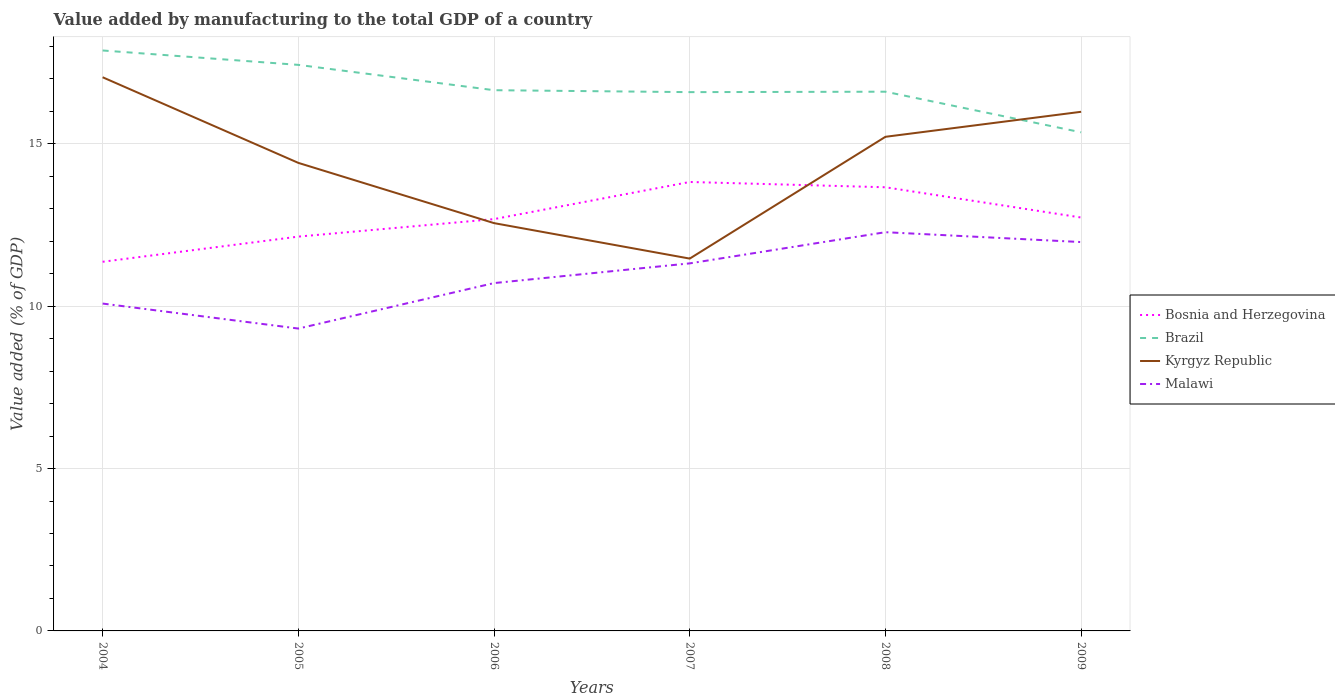How many different coloured lines are there?
Provide a succinct answer. 4. Does the line corresponding to Malawi intersect with the line corresponding to Kyrgyz Republic?
Keep it short and to the point. No. Across all years, what is the maximum value added by manufacturing to the total GDP in Kyrgyz Republic?
Your answer should be compact. 11.47. What is the total value added by manufacturing to the total GDP in Bosnia and Herzegovina in the graph?
Your response must be concise. -2.29. What is the difference between the highest and the second highest value added by manufacturing to the total GDP in Bosnia and Herzegovina?
Provide a short and direct response. 2.46. What is the difference between the highest and the lowest value added by manufacturing to the total GDP in Brazil?
Your response must be concise. 2. How many lines are there?
Your answer should be compact. 4. How many years are there in the graph?
Provide a succinct answer. 6. What is the difference between two consecutive major ticks on the Y-axis?
Give a very brief answer. 5. Does the graph contain any zero values?
Give a very brief answer. No. Where does the legend appear in the graph?
Your answer should be very brief. Center right. What is the title of the graph?
Give a very brief answer. Value added by manufacturing to the total GDP of a country. Does "Equatorial Guinea" appear as one of the legend labels in the graph?
Provide a short and direct response. No. What is the label or title of the X-axis?
Provide a succinct answer. Years. What is the label or title of the Y-axis?
Provide a succinct answer. Value added (% of GDP). What is the Value added (% of GDP) of Bosnia and Herzegovina in 2004?
Keep it short and to the point. 11.37. What is the Value added (% of GDP) of Brazil in 2004?
Your answer should be compact. 17.88. What is the Value added (% of GDP) in Kyrgyz Republic in 2004?
Your answer should be compact. 17.05. What is the Value added (% of GDP) of Malawi in 2004?
Give a very brief answer. 10.08. What is the Value added (% of GDP) in Bosnia and Herzegovina in 2005?
Your answer should be compact. 12.14. What is the Value added (% of GDP) of Brazil in 2005?
Your answer should be very brief. 17.43. What is the Value added (% of GDP) in Kyrgyz Republic in 2005?
Make the answer very short. 14.41. What is the Value added (% of GDP) of Malawi in 2005?
Provide a succinct answer. 9.31. What is the Value added (% of GDP) of Bosnia and Herzegovina in 2006?
Your response must be concise. 12.68. What is the Value added (% of GDP) in Brazil in 2006?
Make the answer very short. 16.65. What is the Value added (% of GDP) in Kyrgyz Republic in 2006?
Make the answer very short. 12.56. What is the Value added (% of GDP) of Malawi in 2006?
Make the answer very short. 10.71. What is the Value added (% of GDP) of Bosnia and Herzegovina in 2007?
Offer a terse response. 13.83. What is the Value added (% of GDP) in Brazil in 2007?
Your response must be concise. 16.59. What is the Value added (% of GDP) of Kyrgyz Republic in 2007?
Your answer should be compact. 11.47. What is the Value added (% of GDP) in Malawi in 2007?
Provide a short and direct response. 11.32. What is the Value added (% of GDP) of Bosnia and Herzegovina in 2008?
Keep it short and to the point. 13.66. What is the Value added (% of GDP) of Brazil in 2008?
Offer a very short reply. 16.61. What is the Value added (% of GDP) in Kyrgyz Republic in 2008?
Provide a succinct answer. 15.22. What is the Value added (% of GDP) in Malawi in 2008?
Offer a terse response. 12.28. What is the Value added (% of GDP) of Bosnia and Herzegovina in 2009?
Your response must be concise. 12.73. What is the Value added (% of GDP) of Brazil in 2009?
Your answer should be very brief. 15.36. What is the Value added (% of GDP) of Kyrgyz Republic in 2009?
Your response must be concise. 15.99. What is the Value added (% of GDP) of Malawi in 2009?
Provide a succinct answer. 11.98. Across all years, what is the maximum Value added (% of GDP) in Bosnia and Herzegovina?
Make the answer very short. 13.83. Across all years, what is the maximum Value added (% of GDP) of Brazil?
Make the answer very short. 17.88. Across all years, what is the maximum Value added (% of GDP) in Kyrgyz Republic?
Your response must be concise. 17.05. Across all years, what is the maximum Value added (% of GDP) in Malawi?
Provide a short and direct response. 12.28. Across all years, what is the minimum Value added (% of GDP) in Bosnia and Herzegovina?
Offer a terse response. 11.37. Across all years, what is the minimum Value added (% of GDP) of Brazil?
Keep it short and to the point. 15.36. Across all years, what is the minimum Value added (% of GDP) in Kyrgyz Republic?
Your answer should be compact. 11.47. Across all years, what is the minimum Value added (% of GDP) in Malawi?
Keep it short and to the point. 9.31. What is the total Value added (% of GDP) in Bosnia and Herzegovina in the graph?
Your answer should be very brief. 76.42. What is the total Value added (% of GDP) of Brazil in the graph?
Offer a very short reply. 100.52. What is the total Value added (% of GDP) of Kyrgyz Republic in the graph?
Offer a very short reply. 86.7. What is the total Value added (% of GDP) of Malawi in the graph?
Keep it short and to the point. 65.68. What is the difference between the Value added (% of GDP) of Bosnia and Herzegovina in 2004 and that in 2005?
Keep it short and to the point. -0.78. What is the difference between the Value added (% of GDP) of Brazil in 2004 and that in 2005?
Your answer should be compact. 0.44. What is the difference between the Value added (% of GDP) of Kyrgyz Republic in 2004 and that in 2005?
Your response must be concise. 2.64. What is the difference between the Value added (% of GDP) of Malawi in 2004 and that in 2005?
Your answer should be very brief. 0.77. What is the difference between the Value added (% of GDP) in Bosnia and Herzegovina in 2004 and that in 2006?
Keep it short and to the point. -1.31. What is the difference between the Value added (% of GDP) of Brazil in 2004 and that in 2006?
Keep it short and to the point. 1.22. What is the difference between the Value added (% of GDP) of Kyrgyz Republic in 2004 and that in 2006?
Your answer should be compact. 4.49. What is the difference between the Value added (% of GDP) in Malawi in 2004 and that in 2006?
Your answer should be compact. -0.63. What is the difference between the Value added (% of GDP) of Bosnia and Herzegovina in 2004 and that in 2007?
Your answer should be very brief. -2.46. What is the difference between the Value added (% of GDP) of Brazil in 2004 and that in 2007?
Provide a succinct answer. 1.28. What is the difference between the Value added (% of GDP) in Kyrgyz Republic in 2004 and that in 2007?
Your response must be concise. 5.58. What is the difference between the Value added (% of GDP) of Malawi in 2004 and that in 2007?
Provide a short and direct response. -1.24. What is the difference between the Value added (% of GDP) of Bosnia and Herzegovina in 2004 and that in 2008?
Provide a short and direct response. -2.29. What is the difference between the Value added (% of GDP) of Brazil in 2004 and that in 2008?
Keep it short and to the point. 1.27. What is the difference between the Value added (% of GDP) of Kyrgyz Republic in 2004 and that in 2008?
Your answer should be very brief. 1.83. What is the difference between the Value added (% of GDP) of Malawi in 2004 and that in 2008?
Ensure brevity in your answer.  -2.2. What is the difference between the Value added (% of GDP) of Bosnia and Herzegovina in 2004 and that in 2009?
Make the answer very short. -1.36. What is the difference between the Value added (% of GDP) in Brazil in 2004 and that in 2009?
Ensure brevity in your answer.  2.52. What is the difference between the Value added (% of GDP) of Kyrgyz Republic in 2004 and that in 2009?
Your answer should be very brief. 1.06. What is the difference between the Value added (% of GDP) in Malawi in 2004 and that in 2009?
Your answer should be compact. -1.89. What is the difference between the Value added (% of GDP) of Bosnia and Herzegovina in 2005 and that in 2006?
Your answer should be very brief. -0.54. What is the difference between the Value added (% of GDP) of Brazil in 2005 and that in 2006?
Provide a succinct answer. 0.78. What is the difference between the Value added (% of GDP) in Kyrgyz Republic in 2005 and that in 2006?
Your answer should be very brief. 1.86. What is the difference between the Value added (% of GDP) of Malawi in 2005 and that in 2006?
Your answer should be compact. -1.4. What is the difference between the Value added (% of GDP) of Bosnia and Herzegovina in 2005 and that in 2007?
Provide a short and direct response. -1.68. What is the difference between the Value added (% of GDP) in Brazil in 2005 and that in 2007?
Offer a very short reply. 0.84. What is the difference between the Value added (% of GDP) in Kyrgyz Republic in 2005 and that in 2007?
Your answer should be very brief. 2.95. What is the difference between the Value added (% of GDP) of Malawi in 2005 and that in 2007?
Your answer should be compact. -2.01. What is the difference between the Value added (% of GDP) of Bosnia and Herzegovina in 2005 and that in 2008?
Your answer should be very brief. -1.52. What is the difference between the Value added (% of GDP) of Brazil in 2005 and that in 2008?
Give a very brief answer. 0.83. What is the difference between the Value added (% of GDP) in Kyrgyz Republic in 2005 and that in 2008?
Ensure brevity in your answer.  -0.8. What is the difference between the Value added (% of GDP) in Malawi in 2005 and that in 2008?
Your answer should be very brief. -2.97. What is the difference between the Value added (% of GDP) in Bosnia and Herzegovina in 2005 and that in 2009?
Your answer should be very brief. -0.59. What is the difference between the Value added (% of GDP) of Brazil in 2005 and that in 2009?
Offer a very short reply. 2.08. What is the difference between the Value added (% of GDP) in Kyrgyz Republic in 2005 and that in 2009?
Keep it short and to the point. -1.57. What is the difference between the Value added (% of GDP) of Malawi in 2005 and that in 2009?
Provide a short and direct response. -2.66. What is the difference between the Value added (% of GDP) in Bosnia and Herzegovina in 2006 and that in 2007?
Your answer should be very brief. -1.14. What is the difference between the Value added (% of GDP) of Brazil in 2006 and that in 2007?
Make the answer very short. 0.06. What is the difference between the Value added (% of GDP) in Kyrgyz Republic in 2006 and that in 2007?
Your response must be concise. 1.09. What is the difference between the Value added (% of GDP) of Malawi in 2006 and that in 2007?
Offer a terse response. -0.61. What is the difference between the Value added (% of GDP) in Bosnia and Herzegovina in 2006 and that in 2008?
Ensure brevity in your answer.  -0.98. What is the difference between the Value added (% of GDP) in Brazil in 2006 and that in 2008?
Give a very brief answer. 0.05. What is the difference between the Value added (% of GDP) in Kyrgyz Republic in 2006 and that in 2008?
Your response must be concise. -2.66. What is the difference between the Value added (% of GDP) of Malawi in 2006 and that in 2008?
Keep it short and to the point. -1.57. What is the difference between the Value added (% of GDP) in Bosnia and Herzegovina in 2006 and that in 2009?
Your response must be concise. -0.05. What is the difference between the Value added (% of GDP) in Brazil in 2006 and that in 2009?
Keep it short and to the point. 1.3. What is the difference between the Value added (% of GDP) in Kyrgyz Republic in 2006 and that in 2009?
Offer a terse response. -3.43. What is the difference between the Value added (% of GDP) of Malawi in 2006 and that in 2009?
Ensure brevity in your answer.  -1.26. What is the difference between the Value added (% of GDP) in Bosnia and Herzegovina in 2007 and that in 2008?
Your answer should be very brief. 0.16. What is the difference between the Value added (% of GDP) in Brazil in 2007 and that in 2008?
Give a very brief answer. -0.01. What is the difference between the Value added (% of GDP) of Kyrgyz Republic in 2007 and that in 2008?
Provide a succinct answer. -3.75. What is the difference between the Value added (% of GDP) of Malawi in 2007 and that in 2008?
Make the answer very short. -0.96. What is the difference between the Value added (% of GDP) of Bosnia and Herzegovina in 2007 and that in 2009?
Offer a very short reply. 1.09. What is the difference between the Value added (% of GDP) of Brazil in 2007 and that in 2009?
Your answer should be very brief. 1.24. What is the difference between the Value added (% of GDP) of Kyrgyz Republic in 2007 and that in 2009?
Keep it short and to the point. -4.52. What is the difference between the Value added (% of GDP) in Malawi in 2007 and that in 2009?
Your answer should be very brief. -0.66. What is the difference between the Value added (% of GDP) of Bosnia and Herzegovina in 2008 and that in 2009?
Keep it short and to the point. 0.93. What is the difference between the Value added (% of GDP) in Brazil in 2008 and that in 2009?
Provide a succinct answer. 1.25. What is the difference between the Value added (% of GDP) in Kyrgyz Republic in 2008 and that in 2009?
Your answer should be very brief. -0.77. What is the difference between the Value added (% of GDP) in Malawi in 2008 and that in 2009?
Offer a very short reply. 0.3. What is the difference between the Value added (% of GDP) of Bosnia and Herzegovina in 2004 and the Value added (% of GDP) of Brazil in 2005?
Keep it short and to the point. -6.06. What is the difference between the Value added (% of GDP) of Bosnia and Herzegovina in 2004 and the Value added (% of GDP) of Kyrgyz Republic in 2005?
Your answer should be very brief. -3.05. What is the difference between the Value added (% of GDP) in Bosnia and Herzegovina in 2004 and the Value added (% of GDP) in Malawi in 2005?
Your response must be concise. 2.06. What is the difference between the Value added (% of GDP) of Brazil in 2004 and the Value added (% of GDP) of Kyrgyz Republic in 2005?
Your answer should be very brief. 3.46. What is the difference between the Value added (% of GDP) of Brazil in 2004 and the Value added (% of GDP) of Malawi in 2005?
Offer a terse response. 8.56. What is the difference between the Value added (% of GDP) of Kyrgyz Republic in 2004 and the Value added (% of GDP) of Malawi in 2005?
Give a very brief answer. 7.74. What is the difference between the Value added (% of GDP) in Bosnia and Herzegovina in 2004 and the Value added (% of GDP) in Brazil in 2006?
Give a very brief answer. -5.28. What is the difference between the Value added (% of GDP) of Bosnia and Herzegovina in 2004 and the Value added (% of GDP) of Kyrgyz Republic in 2006?
Your response must be concise. -1.19. What is the difference between the Value added (% of GDP) of Bosnia and Herzegovina in 2004 and the Value added (% of GDP) of Malawi in 2006?
Provide a succinct answer. 0.66. What is the difference between the Value added (% of GDP) of Brazil in 2004 and the Value added (% of GDP) of Kyrgyz Republic in 2006?
Give a very brief answer. 5.32. What is the difference between the Value added (% of GDP) of Brazil in 2004 and the Value added (% of GDP) of Malawi in 2006?
Your answer should be very brief. 7.16. What is the difference between the Value added (% of GDP) of Kyrgyz Republic in 2004 and the Value added (% of GDP) of Malawi in 2006?
Keep it short and to the point. 6.34. What is the difference between the Value added (% of GDP) of Bosnia and Herzegovina in 2004 and the Value added (% of GDP) of Brazil in 2007?
Give a very brief answer. -5.22. What is the difference between the Value added (% of GDP) in Bosnia and Herzegovina in 2004 and the Value added (% of GDP) in Kyrgyz Republic in 2007?
Give a very brief answer. -0.1. What is the difference between the Value added (% of GDP) in Bosnia and Herzegovina in 2004 and the Value added (% of GDP) in Malawi in 2007?
Provide a succinct answer. 0.05. What is the difference between the Value added (% of GDP) in Brazil in 2004 and the Value added (% of GDP) in Kyrgyz Republic in 2007?
Give a very brief answer. 6.41. What is the difference between the Value added (% of GDP) of Brazil in 2004 and the Value added (% of GDP) of Malawi in 2007?
Make the answer very short. 6.56. What is the difference between the Value added (% of GDP) in Kyrgyz Republic in 2004 and the Value added (% of GDP) in Malawi in 2007?
Offer a very short reply. 5.73. What is the difference between the Value added (% of GDP) in Bosnia and Herzegovina in 2004 and the Value added (% of GDP) in Brazil in 2008?
Your answer should be compact. -5.24. What is the difference between the Value added (% of GDP) in Bosnia and Herzegovina in 2004 and the Value added (% of GDP) in Kyrgyz Republic in 2008?
Your answer should be very brief. -3.85. What is the difference between the Value added (% of GDP) in Bosnia and Herzegovina in 2004 and the Value added (% of GDP) in Malawi in 2008?
Your answer should be very brief. -0.91. What is the difference between the Value added (% of GDP) in Brazil in 2004 and the Value added (% of GDP) in Kyrgyz Republic in 2008?
Provide a succinct answer. 2.66. What is the difference between the Value added (% of GDP) in Brazil in 2004 and the Value added (% of GDP) in Malawi in 2008?
Give a very brief answer. 5.6. What is the difference between the Value added (% of GDP) of Kyrgyz Republic in 2004 and the Value added (% of GDP) of Malawi in 2008?
Keep it short and to the point. 4.77. What is the difference between the Value added (% of GDP) in Bosnia and Herzegovina in 2004 and the Value added (% of GDP) in Brazil in 2009?
Offer a very short reply. -3.99. What is the difference between the Value added (% of GDP) in Bosnia and Herzegovina in 2004 and the Value added (% of GDP) in Kyrgyz Republic in 2009?
Provide a succinct answer. -4.62. What is the difference between the Value added (% of GDP) in Bosnia and Herzegovina in 2004 and the Value added (% of GDP) in Malawi in 2009?
Provide a short and direct response. -0.61. What is the difference between the Value added (% of GDP) of Brazil in 2004 and the Value added (% of GDP) of Kyrgyz Republic in 2009?
Your answer should be very brief. 1.89. What is the difference between the Value added (% of GDP) of Brazil in 2004 and the Value added (% of GDP) of Malawi in 2009?
Offer a very short reply. 5.9. What is the difference between the Value added (% of GDP) of Kyrgyz Republic in 2004 and the Value added (% of GDP) of Malawi in 2009?
Ensure brevity in your answer.  5.08. What is the difference between the Value added (% of GDP) in Bosnia and Herzegovina in 2005 and the Value added (% of GDP) in Brazil in 2006?
Give a very brief answer. -4.51. What is the difference between the Value added (% of GDP) of Bosnia and Herzegovina in 2005 and the Value added (% of GDP) of Kyrgyz Republic in 2006?
Offer a terse response. -0.42. What is the difference between the Value added (% of GDP) of Bosnia and Herzegovina in 2005 and the Value added (% of GDP) of Malawi in 2006?
Your answer should be compact. 1.43. What is the difference between the Value added (% of GDP) in Brazil in 2005 and the Value added (% of GDP) in Kyrgyz Republic in 2006?
Your answer should be compact. 4.87. What is the difference between the Value added (% of GDP) of Brazil in 2005 and the Value added (% of GDP) of Malawi in 2006?
Provide a short and direct response. 6.72. What is the difference between the Value added (% of GDP) in Kyrgyz Republic in 2005 and the Value added (% of GDP) in Malawi in 2006?
Your answer should be very brief. 3.7. What is the difference between the Value added (% of GDP) in Bosnia and Herzegovina in 2005 and the Value added (% of GDP) in Brazil in 2007?
Provide a short and direct response. -4.45. What is the difference between the Value added (% of GDP) in Bosnia and Herzegovina in 2005 and the Value added (% of GDP) in Kyrgyz Republic in 2007?
Provide a short and direct response. 0.68. What is the difference between the Value added (% of GDP) of Bosnia and Herzegovina in 2005 and the Value added (% of GDP) of Malawi in 2007?
Offer a terse response. 0.82. What is the difference between the Value added (% of GDP) in Brazil in 2005 and the Value added (% of GDP) in Kyrgyz Republic in 2007?
Give a very brief answer. 5.97. What is the difference between the Value added (% of GDP) of Brazil in 2005 and the Value added (% of GDP) of Malawi in 2007?
Provide a succinct answer. 6.11. What is the difference between the Value added (% of GDP) in Kyrgyz Republic in 2005 and the Value added (% of GDP) in Malawi in 2007?
Offer a terse response. 3.09. What is the difference between the Value added (% of GDP) of Bosnia and Herzegovina in 2005 and the Value added (% of GDP) of Brazil in 2008?
Your response must be concise. -4.46. What is the difference between the Value added (% of GDP) in Bosnia and Herzegovina in 2005 and the Value added (% of GDP) in Kyrgyz Republic in 2008?
Keep it short and to the point. -3.07. What is the difference between the Value added (% of GDP) of Bosnia and Herzegovina in 2005 and the Value added (% of GDP) of Malawi in 2008?
Provide a succinct answer. -0.14. What is the difference between the Value added (% of GDP) of Brazil in 2005 and the Value added (% of GDP) of Kyrgyz Republic in 2008?
Offer a very short reply. 2.22. What is the difference between the Value added (% of GDP) of Brazil in 2005 and the Value added (% of GDP) of Malawi in 2008?
Your response must be concise. 5.15. What is the difference between the Value added (% of GDP) of Kyrgyz Republic in 2005 and the Value added (% of GDP) of Malawi in 2008?
Keep it short and to the point. 2.13. What is the difference between the Value added (% of GDP) in Bosnia and Herzegovina in 2005 and the Value added (% of GDP) in Brazil in 2009?
Your answer should be compact. -3.21. What is the difference between the Value added (% of GDP) in Bosnia and Herzegovina in 2005 and the Value added (% of GDP) in Kyrgyz Republic in 2009?
Make the answer very short. -3.84. What is the difference between the Value added (% of GDP) of Bosnia and Herzegovina in 2005 and the Value added (% of GDP) of Malawi in 2009?
Your response must be concise. 0.17. What is the difference between the Value added (% of GDP) of Brazil in 2005 and the Value added (% of GDP) of Kyrgyz Republic in 2009?
Provide a short and direct response. 1.44. What is the difference between the Value added (% of GDP) of Brazil in 2005 and the Value added (% of GDP) of Malawi in 2009?
Offer a terse response. 5.46. What is the difference between the Value added (% of GDP) in Kyrgyz Republic in 2005 and the Value added (% of GDP) in Malawi in 2009?
Keep it short and to the point. 2.44. What is the difference between the Value added (% of GDP) of Bosnia and Herzegovina in 2006 and the Value added (% of GDP) of Brazil in 2007?
Provide a short and direct response. -3.91. What is the difference between the Value added (% of GDP) in Bosnia and Herzegovina in 2006 and the Value added (% of GDP) in Kyrgyz Republic in 2007?
Keep it short and to the point. 1.22. What is the difference between the Value added (% of GDP) in Bosnia and Herzegovina in 2006 and the Value added (% of GDP) in Malawi in 2007?
Ensure brevity in your answer.  1.36. What is the difference between the Value added (% of GDP) of Brazil in 2006 and the Value added (% of GDP) of Kyrgyz Republic in 2007?
Make the answer very short. 5.19. What is the difference between the Value added (% of GDP) in Brazil in 2006 and the Value added (% of GDP) in Malawi in 2007?
Provide a succinct answer. 5.33. What is the difference between the Value added (% of GDP) of Kyrgyz Republic in 2006 and the Value added (% of GDP) of Malawi in 2007?
Make the answer very short. 1.24. What is the difference between the Value added (% of GDP) of Bosnia and Herzegovina in 2006 and the Value added (% of GDP) of Brazil in 2008?
Offer a very short reply. -3.92. What is the difference between the Value added (% of GDP) of Bosnia and Herzegovina in 2006 and the Value added (% of GDP) of Kyrgyz Republic in 2008?
Provide a succinct answer. -2.53. What is the difference between the Value added (% of GDP) of Bosnia and Herzegovina in 2006 and the Value added (% of GDP) of Malawi in 2008?
Give a very brief answer. 0.4. What is the difference between the Value added (% of GDP) in Brazil in 2006 and the Value added (% of GDP) in Kyrgyz Republic in 2008?
Your answer should be very brief. 1.44. What is the difference between the Value added (% of GDP) of Brazil in 2006 and the Value added (% of GDP) of Malawi in 2008?
Offer a terse response. 4.37. What is the difference between the Value added (% of GDP) of Kyrgyz Republic in 2006 and the Value added (% of GDP) of Malawi in 2008?
Your response must be concise. 0.28. What is the difference between the Value added (% of GDP) in Bosnia and Herzegovina in 2006 and the Value added (% of GDP) in Brazil in 2009?
Your answer should be compact. -2.67. What is the difference between the Value added (% of GDP) of Bosnia and Herzegovina in 2006 and the Value added (% of GDP) of Kyrgyz Republic in 2009?
Your answer should be compact. -3.31. What is the difference between the Value added (% of GDP) of Bosnia and Herzegovina in 2006 and the Value added (% of GDP) of Malawi in 2009?
Offer a terse response. 0.71. What is the difference between the Value added (% of GDP) of Brazil in 2006 and the Value added (% of GDP) of Kyrgyz Republic in 2009?
Offer a very short reply. 0.66. What is the difference between the Value added (% of GDP) in Brazil in 2006 and the Value added (% of GDP) in Malawi in 2009?
Your answer should be very brief. 4.68. What is the difference between the Value added (% of GDP) in Kyrgyz Republic in 2006 and the Value added (% of GDP) in Malawi in 2009?
Keep it short and to the point. 0.58. What is the difference between the Value added (% of GDP) in Bosnia and Herzegovina in 2007 and the Value added (% of GDP) in Brazil in 2008?
Offer a very short reply. -2.78. What is the difference between the Value added (% of GDP) of Bosnia and Herzegovina in 2007 and the Value added (% of GDP) of Kyrgyz Republic in 2008?
Ensure brevity in your answer.  -1.39. What is the difference between the Value added (% of GDP) in Bosnia and Herzegovina in 2007 and the Value added (% of GDP) in Malawi in 2008?
Your answer should be compact. 1.55. What is the difference between the Value added (% of GDP) of Brazil in 2007 and the Value added (% of GDP) of Kyrgyz Republic in 2008?
Your response must be concise. 1.38. What is the difference between the Value added (% of GDP) of Brazil in 2007 and the Value added (% of GDP) of Malawi in 2008?
Give a very brief answer. 4.31. What is the difference between the Value added (% of GDP) of Kyrgyz Republic in 2007 and the Value added (% of GDP) of Malawi in 2008?
Your answer should be very brief. -0.81. What is the difference between the Value added (% of GDP) of Bosnia and Herzegovina in 2007 and the Value added (% of GDP) of Brazil in 2009?
Your response must be concise. -1.53. What is the difference between the Value added (% of GDP) in Bosnia and Herzegovina in 2007 and the Value added (% of GDP) in Kyrgyz Republic in 2009?
Your answer should be compact. -2.16. What is the difference between the Value added (% of GDP) of Bosnia and Herzegovina in 2007 and the Value added (% of GDP) of Malawi in 2009?
Make the answer very short. 1.85. What is the difference between the Value added (% of GDP) of Brazil in 2007 and the Value added (% of GDP) of Kyrgyz Republic in 2009?
Offer a terse response. 0.61. What is the difference between the Value added (% of GDP) in Brazil in 2007 and the Value added (% of GDP) in Malawi in 2009?
Keep it short and to the point. 4.62. What is the difference between the Value added (% of GDP) of Kyrgyz Republic in 2007 and the Value added (% of GDP) of Malawi in 2009?
Keep it short and to the point. -0.51. What is the difference between the Value added (% of GDP) of Bosnia and Herzegovina in 2008 and the Value added (% of GDP) of Brazil in 2009?
Provide a succinct answer. -1.69. What is the difference between the Value added (% of GDP) of Bosnia and Herzegovina in 2008 and the Value added (% of GDP) of Kyrgyz Republic in 2009?
Your answer should be compact. -2.32. What is the difference between the Value added (% of GDP) in Bosnia and Herzegovina in 2008 and the Value added (% of GDP) in Malawi in 2009?
Provide a short and direct response. 1.69. What is the difference between the Value added (% of GDP) in Brazil in 2008 and the Value added (% of GDP) in Kyrgyz Republic in 2009?
Your response must be concise. 0.62. What is the difference between the Value added (% of GDP) of Brazil in 2008 and the Value added (% of GDP) of Malawi in 2009?
Offer a terse response. 4.63. What is the difference between the Value added (% of GDP) of Kyrgyz Republic in 2008 and the Value added (% of GDP) of Malawi in 2009?
Give a very brief answer. 3.24. What is the average Value added (% of GDP) in Bosnia and Herzegovina per year?
Your response must be concise. 12.74. What is the average Value added (% of GDP) in Brazil per year?
Keep it short and to the point. 16.75. What is the average Value added (% of GDP) of Kyrgyz Republic per year?
Offer a terse response. 14.45. What is the average Value added (% of GDP) of Malawi per year?
Offer a very short reply. 10.95. In the year 2004, what is the difference between the Value added (% of GDP) of Bosnia and Herzegovina and Value added (% of GDP) of Brazil?
Give a very brief answer. -6.51. In the year 2004, what is the difference between the Value added (% of GDP) in Bosnia and Herzegovina and Value added (% of GDP) in Kyrgyz Republic?
Provide a succinct answer. -5.68. In the year 2004, what is the difference between the Value added (% of GDP) of Bosnia and Herzegovina and Value added (% of GDP) of Malawi?
Your answer should be compact. 1.29. In the year 2004, what is the difference between the Value added (% of GDP) of Brazil and Value added (% of GDP) of Kyrgyz Republic?
Make the answer very short. 0.82. In the year 2004, what is the difference between the Value added (% of GDP) of Brazil and Value added (% of GDP) of Malawi?
Provide a short and direct response. 7.79. In the year 2004, what is the difference between the Value added (% of GDP) in Kyrgyz Republic and Value added (% of GDP) in Malawi?
Provide a short and direct response. 6.97. In the year 2005, what is the difference between the Value added (% of GDP) in Bosnia and Herzegovina and Value added (% of GDP) in Brazil?
Offer a very short reply. -5.29. In the year 2005, what is the difference between the Value added (% of GDP) in Bosnia and Herzegovina and Value added (% of GDP) in Kyrgyz Republic?
Ensure brevity in your answer.  -2.27. In the year 2005, what is the difference between the Value added (% of GDP) in Bosnia and Herzegovina and Value added (% of GDP) in Malawi?
Make the answer very short. 2.83. In the year 2005, what is the difference between the Value added (% of GDP) in Brazil and Value added (% of GDP) in Kyrgyz Republic?
Keep it short and to the point. 3.02. In the year 2005, what is the difference between the Value added (% of GDP) in Brazil and Value added (% of GDP) in Malawi?
Provide a succinct answer. 8.12. In the year 2005, what is the difference between the Value added (% of GDP) of Kyrgyz Republic and Value added (% of GDP) of Malawi?
Provide a short and direct response. 5.1. In the year 2006, what is the difference between the Value added (% of GDP) of Bosnia and Herzegovina and Value added (% of GDP) of Brazil?
Provide a succinct answer. -3.97. In the year 2006, what is the difference between the Value added (% of GDP) of Bosnia and Herzegovina and Value added (% of GDP) of Kyrgyz Republic?
Keep it short and to the point. 0.12. In the year 2006, what is the difference between the Value added (% of GDP) of Bosnia and Herzegovina and Value added (% of GDP) of Malawi?
Your answer should be very brief. 1.97. In the year 2006, what is the difference between the Value added (% of GDP) of Brazil and Value added (% of GDP) of Kyrgyz Republic?
Your response must be concise. 4.09. In the year 2006, what is the difference between the Value added (% of GDP) in Brazil and Value added (% of GDP) in Malawi?
Provide a short and direct response. 5.94. In the year 2006, what is the difference between the Value added (% of GDP) of Kyrgyz Republic and Value added (% of GDP) of Malawi?
Provide a succinct answer. 1.85. In the year 2007, what is the difference between the Value added (% of GDP) of Bosnia and Herzegovina and Value added (% of GDP) of Brazil?
Your answer should be compact. -2.77. In the year 2007, what is the difference between the Value added (% of GDP) of Bosnia and Herzegovina and Value added (% of GDP) of Kyrgyz Republic?
Your response must be concise. 2.36. In the year 2007, what is the difference between the Value added (% of GDP) in Bosnia and Herzegovina and Value added (% of GDP) in Malawi?
Provide a succinct answer. 2.51. In the year 2007, what is the difference between the Value added (% of GDP) of Brazil and Value added (% of GDP) of Kyrgyz Republic?
Keep it short and to the point. 5.13. In the year 2007, what is the difference between the Value added (% of GDP) of Brazil and Value added (% of GDP) of Malawi?
Give a very brief answer. 5.27. In the year 2007, what is the difference between the Value added (% of GDP) of Kyrgyz Republic and Value added (% of GDP) of Malawi?
Provide a succinct answer. 0.15. In the year 2008, what is the difference between the Value added (% of GDP) in Bosnia and Herzegovina and Value added (% of GDP) in Brazil?
Keep it short and to the point. -2.94. In the year 2008, what is the difference between the Value added (% of GDP) of Bosnia and Herzegovina and Value added (% of GDP) of Kyrgyz Republic?
Offer a very short reply. -1.55. In the year 2008, what is the difference between the Value added (% of GDP) of Bosnia and Herzegovina and Value added (% of GDP) of Malawi?
Your response must be concise. 1.38. In the year 2008, what is the difference between the Value added (% of GDP) in Brazil and Value added (% of GDP) in Kyrgyz Republic?
Give a very brief answer. 1.39. In the year 2008, what is the difference between the Value added (% of GDP) of Brazil and Value added (% of GDP) of Malawi?
Provide a succinct answer. 4.33. In the year 2008, what is the difference between the Value added (% of GDP) in Kyrgyz Republic and Value added (% of GDP) in Malawi?
Make the answer very short. 2.94. In the year 2009, what is the difference between the Value added (% of GDP) in Bosnia and Herzegovina and Value added (% of GDP) in Brazil?
Provide a short and direct response. -2.62. In the year 2009, what is the difference between the Value added (% of GDP) of Bosnia and Herzegovina and Value added (% of GDP) of Kyrgyz Republic?
Ensure brevity in your answer.  -3.26. In the year 2009, what is the difference between the Value added (% of GDP) in Bosnia and Herzegovina and Value added (% of GDP) in Malawi?
Your answer should be very brief. 0.76. In the year 2009, what is the difference between the Value added (% of GDP) of Brazil and Value added (% of GDP) of Kyrgyz Republic?
Your answer should be compact. -0.63. In the year 2009, what is the difference between the Value added (% of GDP) of Brazil and Value added (% of GDP) of Malawi?
Your answer should be very brief. 3.38. In the year 2009, what is the difference between the Value added (% of GDP) of Kyrgyz Republic and Value added (% of GDP) of Malawi?
Provide a short and direct response. 4.01. What is the ratio of the Value added (% of GDP) of Bosnia and Herzegovina in 2004 to that in 2005?
Offer a terse response. 0.94. What is the ratio of the Value added (% of GDP) in Brazil in 2004 to that in 2005?
Keep it short and to the point. 1.03. What is the ratio of the Value added (% of GDP) in Kyrgyz Republic in 2004 to that in 2005?
Provide a short and direct response. 1.18. What is the ratio of the Value added (% of GDP) in Malawi in 2004 to that in 2005?
Your answer should be very brief. 1.08. What is the ratio of the Value added (% of GDP) in Bosnia and Herzegovina in 2004 to that in 2006?
Your answer should be very brief. 0.9. What is the ratio of the Value added (% of GDP) in Brazil in 2004 to that in 2006?
Keep it short and to the point. 1.07. What is the ratio of the Value added (% of GDP) of Kyrgyz Republic in 2004 to that in 2006?
Offer a very short reply. 1.36. What is the ratio of the Value added (% of GDP) in Malawi in 2004 to that in 2006?
Your response must be concise. 0.94. What is the ratio of the Value added (% of GDP) in Bosnia and Herzegovina in 2004 to that in 2007?
Your answer should be compact. 0.82. What is the ratio of the Value added (% of GDP) of Brazil in 2004 to that in 2007?
Provide a short and direct response. 1.08. What is the ratio of the Value added (% of GDP) of Kyrgyz Republic in 2004 to that in 2007?
Make the answer very short. 1.49. What is the ratio of the Value added (% of GDP) in Malawi in 2004 to that in 2007?
Your answer should be very brief. 0.89. What is the ratio of the Value added (% of GDP) of Bosnia and Herzegovina in 2004 to that in 2008?
Provide a succinct answer. 0.83. What is the ratio of the Value added (% of GDP) in Brazil in 2004 to that in 2008?
Provide a succinct answer. 1.08. What is the ratio of the Value added (% of GDP) of Kyrgyz Republic in 2004 to that in 2008?
Make the answer very short. 1.12. What is the ratio of the Value added (% of GDP) of Malawi in 2004 to that in 2008?
Your answer should be very brief. 0.82. What is the ratio of the Value added (% of GDP) in Bosnia and Herzegovina in 2004 to that in 2009?
Provide a succinct answer. 0.89. What is the ratio of the Value added (% of GDP) of Brazil in 2004 to that in 2009?
Provide a short and direct response. 1.16. What is the ratio of the Value added (% of GDP) of Kyrgyz Republic in 2004 to that in 2009?
Your response must be concise. 1.07. What is the ratio of the Value added (% of GDP) in Malawi in 2004 to that in 2009?
Provide a succinct answer. 0.84. What is the ratio of the Value added (% of GDP) in Bosnia and Herzegovina in 2005 to that in 2006?
Keep it short and to the point. 0.96. What is the ratio of the Value added (% of GDP) in Brazil in 2005 to that in 2006?
Ensure brevity in your answer.  1.05. What is the ratio of the Value added (% of GDP) of Kyrgyz Republic in 2005 to that in 2006?
Offer a terse response. 1.15. What is the ratio of the Value added (% of GDP) of Malawi in 2005 to that in 2006?
Your response must be concise. 0.87. What is the ratio of the Value added (% of GDP) in Bosnia and Herzegovina in 2005 to that in 2007?
Give a very brief answer. 0.88. What is the ratio of the Value added (% of GDP) in Brazil in 2005 to that in 2007?
Give a very brief answer. 1.05. What is the ratio of the Value added (% of GDP) in Kyrgyz Republic in 2005 to that in 2007?
Make the answer very short. 1.26. What is the ratio of the Value added (% of GDP) in Malawi in 2005 to that in 2007?
Your answer should be very brief. 0.82. What is the ratio of the Value added (% of GDP) of Bosnia and Herzegovina in 2005 to that in 2008?
Your answer should be compact. 0.89. What is the ratio of the Value added (% of GDP) in Brazil in 2005 to that in 2008?
Offer a terse response. 1.05. What is the ratio of the Value added (% of GDP) of Kyrgyz Republic in 2005 to that in 2008?
Give a very brief answer. 0.95. What is the ratio of the Value added (% of GDP) of Malawi in 2005 to that in 2008?
Provide a short and direct response. 0.76. What is the ratio of the Value added (% of GDP) in Bosnia and Herzegovina in 2005 to that in 2009?
Your answer should be compact. 0.95. What is the ratio of the Value added (% of GDP) in Brazil in 2005 to that in 2009?
Offer a terse response. 1.14. What is the ratio of the Value added (% of GDP) of Kyrgyz Republic in 2005 to that in 2009?
Provide a succinct answer. 0.9. What is the ratio of the Value added (% of GDP) of Malawi in 2005 to that in 2009?
Your answer should be very brief. 0.78. What is the ratio of the Value added (% of GDP) of Bosnia and Herzegovina in 2006 to that in 2007?
Offer a very short reply. 0.92. What is the ratio of the Value added (% of GDP) of Brazil in 2006 to that in 2007?
Make the answer very short. 1. What is the ratio of the Value added (% of GDP) in Kyrgyz Republic in 2006 to that in 2007?
Your answer should be compact. 1.1. What is the ratio of the Value added (% of GDP) of Malawi in 2006 to that in 2007?
Your response must be concise. 0.95. What is the ratio of the Value added (% of GDP) of Bosnia and Herzegovina in 2006 to that in 2008?
Keep it short and to the point. 0.93. What is the ratio of the Value added (% of GDP) of Brazil in 2006 to that in 2008?
Offer a very short reply. 1. What is the ratio of the Value added (% of GDP) of Kyrgyz Republic in 2006 to that in 2008?
Your answer should be compact. 0.83. What is the ratio of the Value added (% of GDP) of Malawi in 2006 to that in 2008?
Your response must be concise. 0.87. What is the ratio of the Value added (% of GDP) in Brazil in 2006 to that in 2009?
Your answer should be very brief. 1.08. What is the ratio of the Value added (% of GDP) of Kyrgyz Republic in 2006 to that in 2009?
Keep it short and to the point. 0.79. What is the ratio of the Value added (% of GDP) of Malawi in 2006 to that in 2009?
Offer a terse response. 0.89. What is the ratio of the Value added (% of GDP) in Bosnia and Herzegovina in 2007 to that in 2008?
Offer a very short reply. 1.01. What is the ratio of the Value added (% of GDP) in Brazil in 2007 to that in 2008?
Offer a terse response. 1. What is the ratio of the Value added (% of GDP) of Kyrgyz Republic in 2007 to that in 2008?
Your answer should be very brief. 0.75. What is the ratio of the Value added (% of GDP) of Malawi in 2007 to that in 2008?
Keep it short and to the point. 0.92. What is the ratio of the Value added (% of GDP) of Bosnia and Herzegovina in 2007 to that in 2009?
Offer a very short reply. 1.09. What is the ratio of the Value added (% of GDP) in Brazil in 2007 to that in 2009?
Provide a short and direct response. 1.08. What is the ratio of the Value added (% of GDP) of Kyrgyz Republic in 2007 to that in 2009?
Keep it short and to the point. 0.72. What is the ratio of the Value added (% of GDP) of Malawi in 2007 to that in 2009?
Make the answer very short. 0.95. What is the ratio of the Value added (% of GDP) in Bosnia and Herzegovina in 2008 to that in 2009?
Make the answer very short. 1.07. What is the ratio of the Value added (% of GDP) in Brazil in 2008 to that in 2009?
Offer a very short reply. 1.08. What is the ratio of the Value added (% of GDP) in Kyrgyz Republic in 2008 to that in 2009?
Your response must be concise. 0.95. What is the ratio of the Value added (% of GDP) in Malawi in 2008 to that in 2009?
Make the answer very short. 1.03. What is the difference between the highest and the second highest Value added (% of GDP) of Bosnia and Herzegovina?
Your response must be concise. 0.16. What is the difference between the highest and the second highest Value added (% of GDP) in Brazil?
Give a very brief answer. 0.44. What is the difference between the highest and the second highest Value added (% of GDP) of Kyrgyz Republic?
Offer a very short reply. 1.06. What is the difference between the highest and the second highest Value added (% of GDP) of Malawi?
Offer a very short reply. 0.3. What is the difference between the highest and the lowest Value added (% of GDP) in Bosnia and Herzegovina?
Offer a terse response. 2.46. What is the difference between the highest and the lowest Value added (% of GDP) in Brazil?
Provide a succinct answer. 2.52. What is the difference between the highest and the lowest Value added (% of GDP) in Kyrgyz Republic?
Provide a succinct answer. 5.58. What is the difference between the highest and the lowest Value added (% of GDP) of Malawi?
Offer a very short reply. 2.97. 